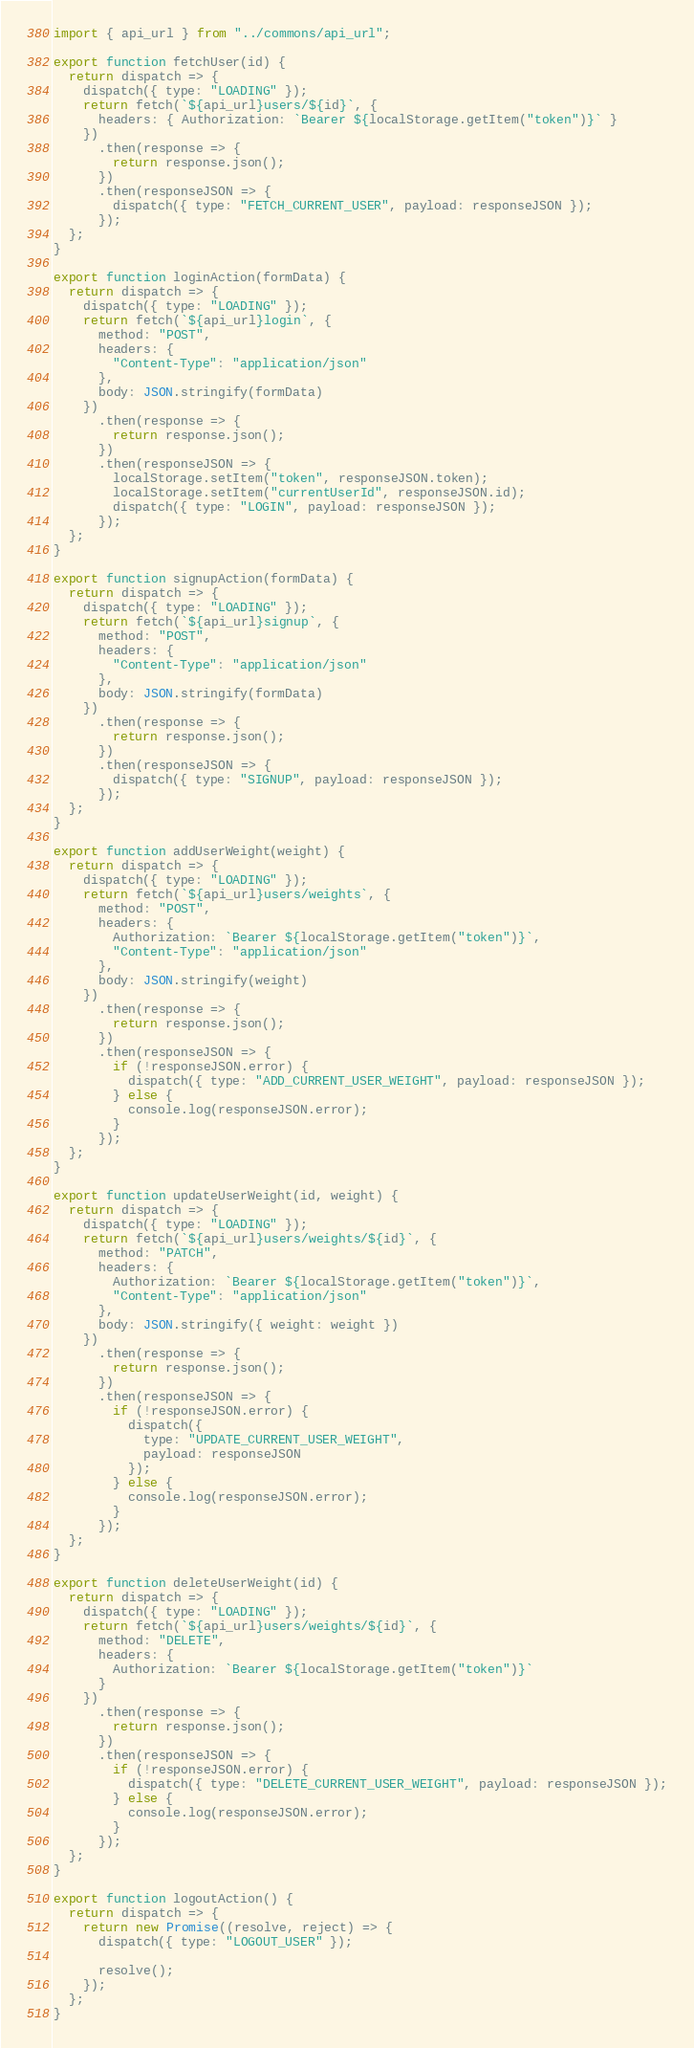Convert code to text. <code><loc_0><loc_0><loc_500><loc_500><_JavaScript_>import { api_url } from "../commons/api_url";

export function fetchUser(id) {
  return dispatch => {
    dispatch({ type: "LOADING" });
    return fetch(`${api_url}users/${id}`, {
      headers: { Authorization: `Bearer ${localStorage.getItem("token")}` }
    })
      .then(response => {
        return response.json();
      })
      .then(responseJSON => {
        dispatch({ type: "FETCH_CURRENT_USER", payload: responseJSON });
      });
  };
}

export function loginAction(formData) {
  return dispatch => {
    dispatch({ type: "LOADING" });
    return fetch(`${api_url}login`, {
      method: "POST",
      headers: {
        "Content-Type": "application/json"
      },
      body: JSON.stringify(formData)
    })
      .then(response => {
        return response.json();
      })
      .then(responseJSON => {
        localStorage.setItem("token", responseJSON.token);
        localStorage.setItem("currentUserId", responseJSON.id);
        dispatch({ type: "LOGIN", payload: responseJSON });
      });
  };
}

export function signupAction(formData) {
  return dispatch => {
    dispatch({ type: "LOADING" });
    return fetch(`${api_url}signup`, {
      method: "POST",
      headers: {
        "Content-Type": "application/json"
      },
      body: JSON.stringify(formData)
    })
      .then(response => {
        return response.json();
      })
      .then(responseJSON => {
        dispatch({ type: "SIGNUP", payload: responseJSON });
      });
  };
}

export function addUserWeight(weight) {
  return dispatch => {
    dispatch({ type: "LOADING" });
    return fetch(`${api_url}users/weights`, {
      method: "POST",
      headers: {
        Authorization: `Bearer ${localStorage.getItem("token")}`,
        "Content-Type": "application/json"
      },
      body: JSON.stringify(weight)
    })
      .then(response => {
        return response.json();
      })
      .then(responseJSON => {
        if (!responseJSON.error) {
          dispatch({ type: "ADD_CURRENT_USER_WEIGHT", payload: responseJSON });
        } else {
          console.log(responseJSON.error);
        }
      });
  };
}

export function updateUserWeight(id, weight) {
  return dispatch => {
    dispatch({ type: "LOADING" });
    return fetch(`${api_url}users/weights/${id}`, {
      method: "PATCH",
      headers: {
        Authorization: `Bearer ${localStorage.getItem("token")}`,
        "Content-Type": "application/json"
      },
      body: JSON.stringify({ weight: weight })
    })
      .then(response => {
        return response.json();
      })
      .then(responseJSON => {
        if (!responseJSON.error) {
          dispatch({
            type: "UPDATE_CURRENT_USER_WEIGHT",
            payload: responseJSON
          });
        } else {
          console.log(responseJSON.error);
        }
      });
  };
}

export function deleteUserWeight(id) {
  return dispatch => {
    dispatch({ type: "LOADING" });
    return fetch(`${api_url}users/weights/${id}`, {
      method: "DELETE",
      headers: {
        Authorization: `Bearer ${localStorage.getItem("token")}`
      }
    })
      .then(response => {
        return response.json();
      })
      .then(responseJSON => {
        if (!responseJSON.error) {
          dispatch({ type: "DELETE_CURRENT_USER_WEIGHT", payload: responseJSON });
        } else {
          console.log(responseJSON.error);
        }
      });
  };
}

export function logoutAction() {
  return dispatch => {
    return new Promise((resolve, reject) => {
      dispatch({ type: "LOGOUT_USER" });

      resolve();
    });
  };
}
</code> 